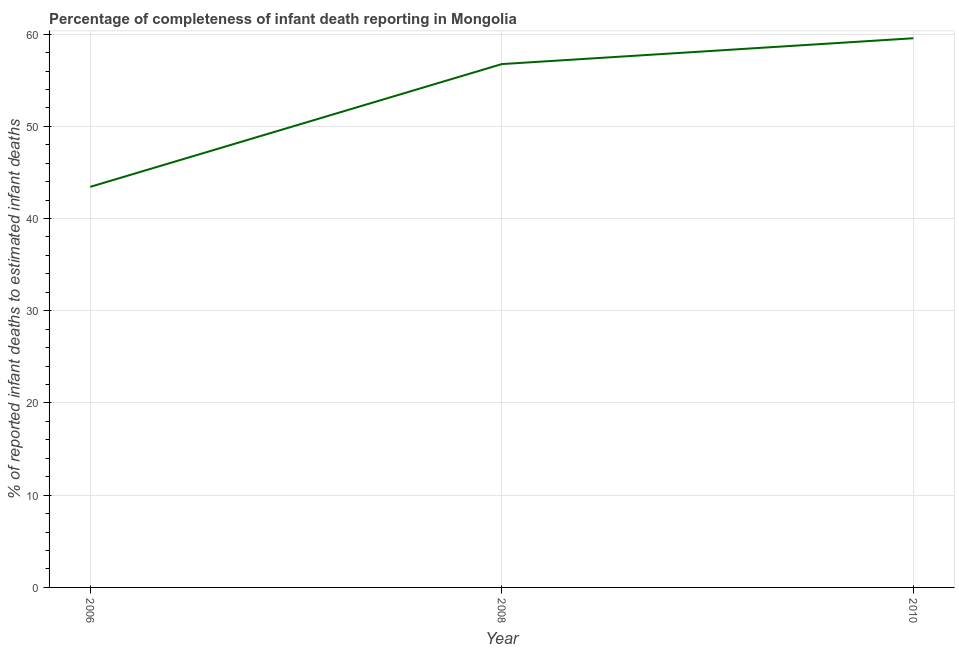What is the completeness of infant death reporting in 2008?
Offer a very short reply. 56.75. Across all years, what is the maximum completeness of infant death reporting?
Offer a very short reply. 59.55. Across all years, what is the minimum completeness of infant death reporting?
Offer a very short reply. 43.44. In which year was the completeness of infant death reporting maximum?
Provide a short and direct response. 2010. In which year was the completeness of infant death reporting minimum?
Offer a terse response. 2006. What is the sum of the completeness of infant death reporting?
Your answer should be compact. 159.74. What is the difference between the completeness of infant death reporting in 2006 and 2010?
Your answer should be very brief. -16.11. What is the average completeness of infant death reporting per year?
Give a very brief answer. 53.25. What is the median completeness of infant death reporting?
Offer a very short reply. 56.75. Do a majority of the years between 2006 and 2008 (inclusive) have completeness of infant death reporting greater than 16 %?
Your answer should be compact. Yes. What is the ratio of the completeness of infant death reporting in 2008 to that in 2010?
Give a very brief answer. 0.95. Is the difference between the completeness of infant death reporting in 2006 and 2008 greater than the difference between any two years?
Offer a terse response. No. What is the difference between the highest and the second highest completeness of infant death reporting?
Your answer should be compact. 2.8. What is the difference between the highest and the lowest completeness of infant death reporting?
Your answer should be very brief. 16.11. In how many years, is the completeness of infant death reporting greater than the average completeness of infant death reporting taken over all years?
Provide a succinct answer. 2. How many lines are there?
Give a very brief answer. 1. What is the difference between two consecutive major ticks on the Y-axis?
Offer a terse response. 10. Are the values on the major ticks of Y-axis written in scientific E-notation?
Give a very brief answer. No. Does the graph contain any zero values?
Provide a succinct answer. No. What is the title of the graph?
Your response must be concise. Percentage of completeness of infant death reporting in Mongolia. What is the label or title of the Y-axis?
Keep it short and to the point. % of reported infant deaths to estimated infant deaths. What is the % of reported infant deaths to estimated infant deaths of 2006?
Make the answer very short. 43.44. What is the % of reported infant deaths to estimated infant deaths of 2008?
Your answer should be compact. 56.75. What is the % of reported infant deaths to estimated infant deaths of 2010?
Offer a very short reply. 59.55. What is the difference between the % of reported infant deaths to estimated infant deaths in 2006 and 2008?
Your answer should be compact. -13.31. What is the difference between the % of reported infant deaths to estimated infant deaths in 2006 and 2010?
Provide a succinct answer. -16.11. What is the difference between the % of reported infant deaths to estimated infant deaths in 2008 and 2010?
Your answer should be very brief. -2.8. What is the ratio of the % of reported infant deaths to estimated infant deaths in 2006 to that in 2008?
Keep it short and to the point. 0.77. What is the ratio of the % of reported infant deaths to estimated infant deaths in 2006 to that in 2010?
Your response must be concise. 0.73. What is the ratio of the % of reported infant deaths to estimated infant deaths in 2008 to that in 2010?
Provide a short and direct response. 0.95. 